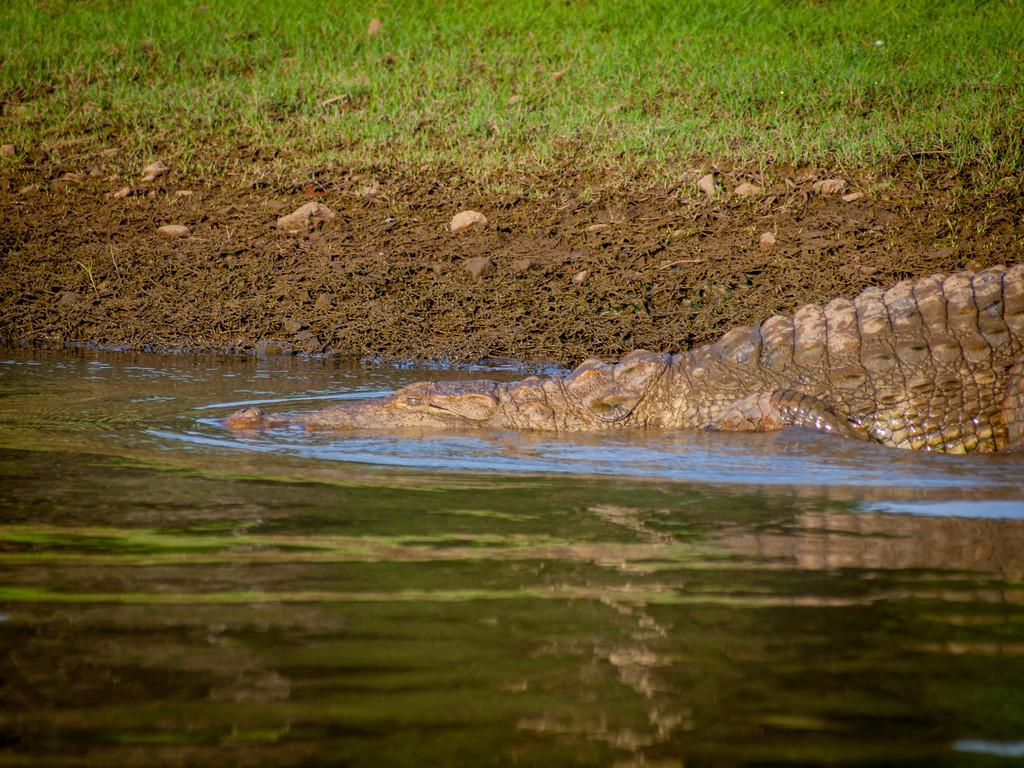What animal is present in the image? There is a crocodile in the image. What is the primary element visible in the image? There is water visible in the image. What type of terrain can be seen in the background of the image? There is mud and grass in the background of the image. What is the value of the cemetery in the image? There is no cemetery present in the image, so it is not possible to determine its value. 